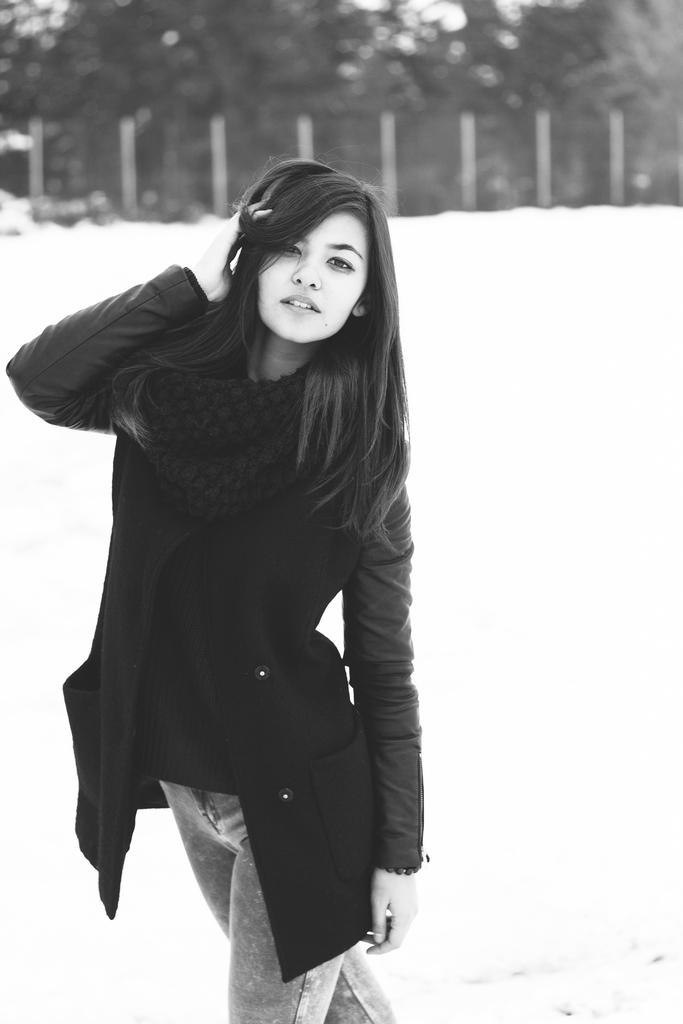What is the color scheme of the image? The image is black and white. Who is present in the image? There is a woman in the image. What is the woman wearing? The woman is wearing a jacket and a scarf. Where is the woman standing? The woman is standing on land. What can be seen at the top of the image? There is a fence at the top of the image, and trees are behind the fence. What type of error can be seen in the image? There is no error present in the image. What is the woman using to sew in the image? There is no needle or sewing activity depicted in the image. 